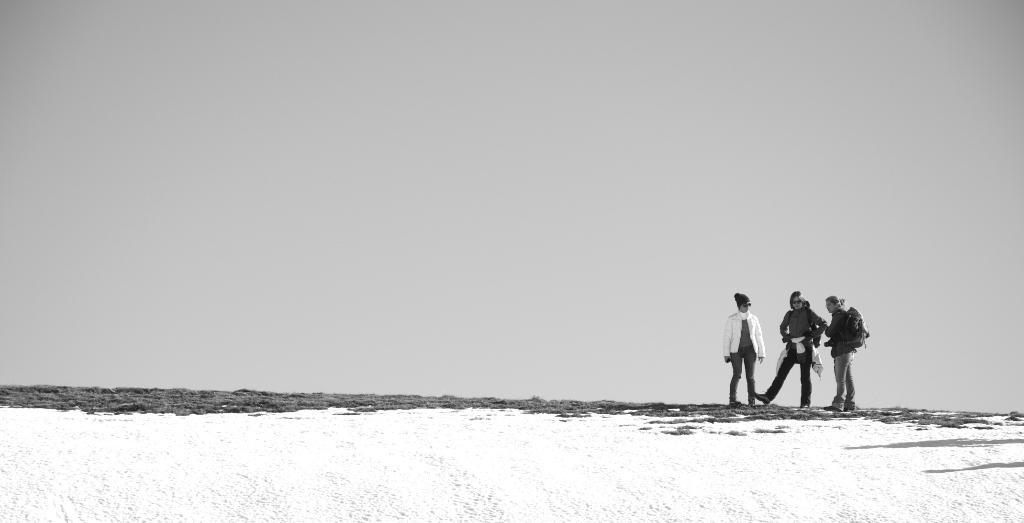How many people are in the image? There are three people in the image. Where are the people located in the image? The people are standing on the left side of the image. What is covering the ground in the image? There is snow on the floor in the image. What is the condition of the sky in the image? The sky is clear in the image. What type of treatment can be seen being administered to the cars in the image? There are no cars present in the image, so no treatment can be observed. 